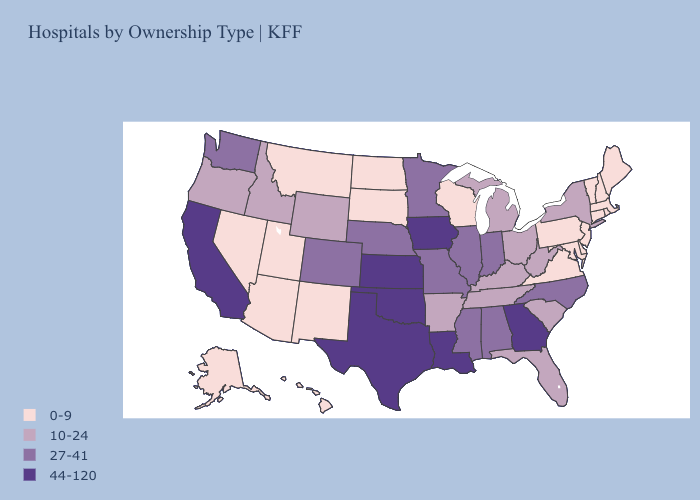Does Kentucky have the lowest value in the USA?
Write a very short answer. No. Name the states that have a value in the range 0-9?
Quick response, please. Alaska, Arizona, Connecticut, Delaware, Hawaii, Maine, Maryland, Massachusetts, Montana, Nevada, New Hampshire, New Jersey, New Mexico, North Dakota, Pennsylvania, Rhode Island, South Dakota, Utah, Vermont, Virginia, Wisconsin. Name the states that have a value in the range 0-9?
Write a very short answer. Alaska, Arizona, Connecticut, Delaware, Hawaii, Maine, Maryland, Massachusetts, Montana, Nevada, New Hampshire, New Jersey, New Mexico, North Dakota, Pennsylvania, Rhode Island, South Dakota, Utah, Vermont, Virginia, Wisconsin. What is the value of Rhode Island?
Give a very brief answer. 0-9. Does the first symbol in the legend represent the smallest category?
Answer briefly. Yes. Does Iowa have the highest value in the USA?
Keep it brief. Yes. What is the value of South Carolina?
Quick response, please. 10-24. Is the legend a continuous bar?
Quick response, please. No. Does Colorado have the highest value in the USA?
Keep it brief. No. Does the map have missing data?
Answer briefly. No. What is the lowest value in the USA?
Give a very brief answer. 0-9. Does Kentucky have the lowest value in the USA?
Give a very brief answer. No. What is the value of Connecticut?
Give a very brief answer. 0-9. What is the highest value in the MidWest ?
Be succinct. 44-120. Does Tennessee have the same value as Nebraska?
Answer briefly. No. 